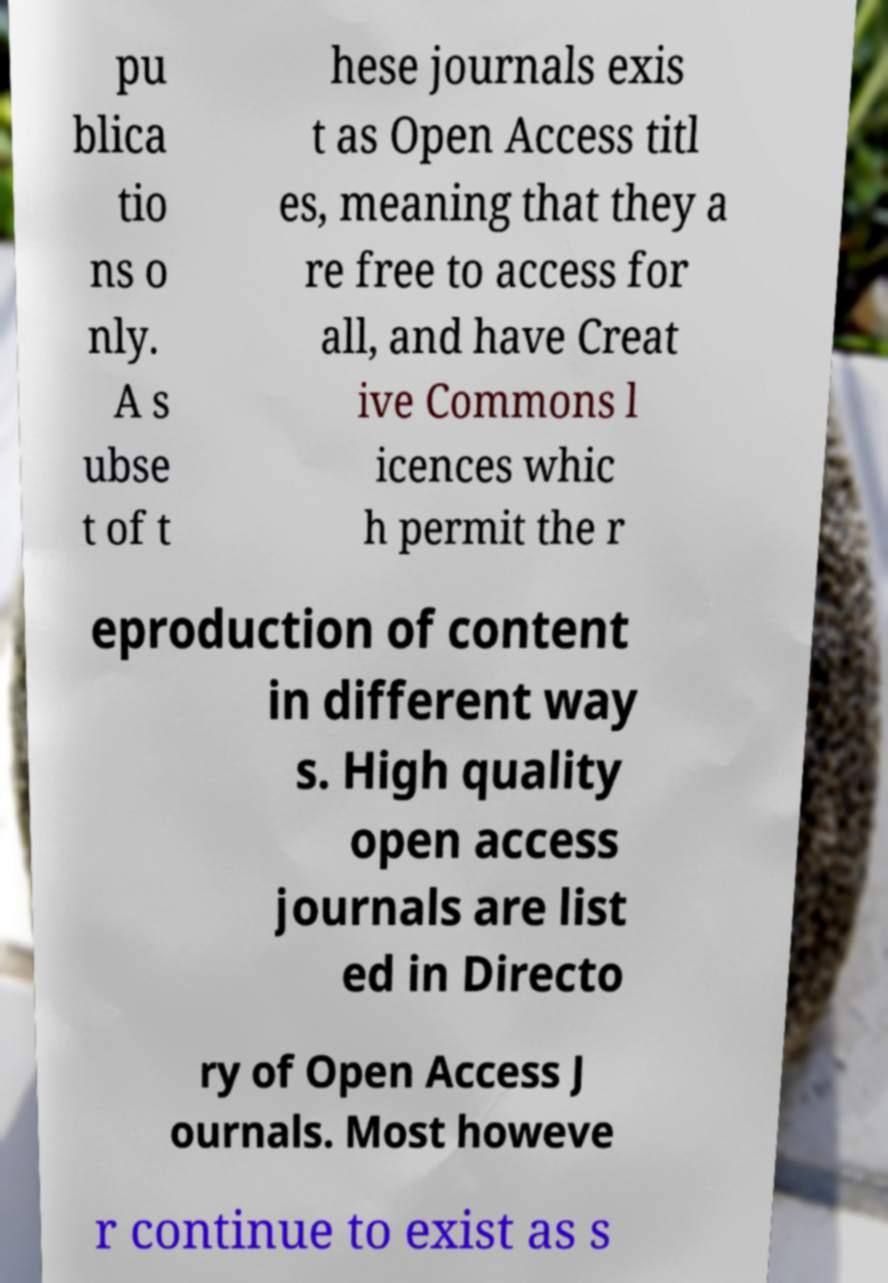There's text embedded in this image that I need extracted. Can you transcribe it verbatim? pu blica tio ns o nly. A s ubse t of t hese journals exis t as Open Access titl es, meaning that they a re free to access for all, and have Creat ive Commons l icences whic h permit the r eproduction of content in different way s. High quality open access journals are list ed in Directo ry of Open Access J ournals. Most howeve r continue to exist as s 